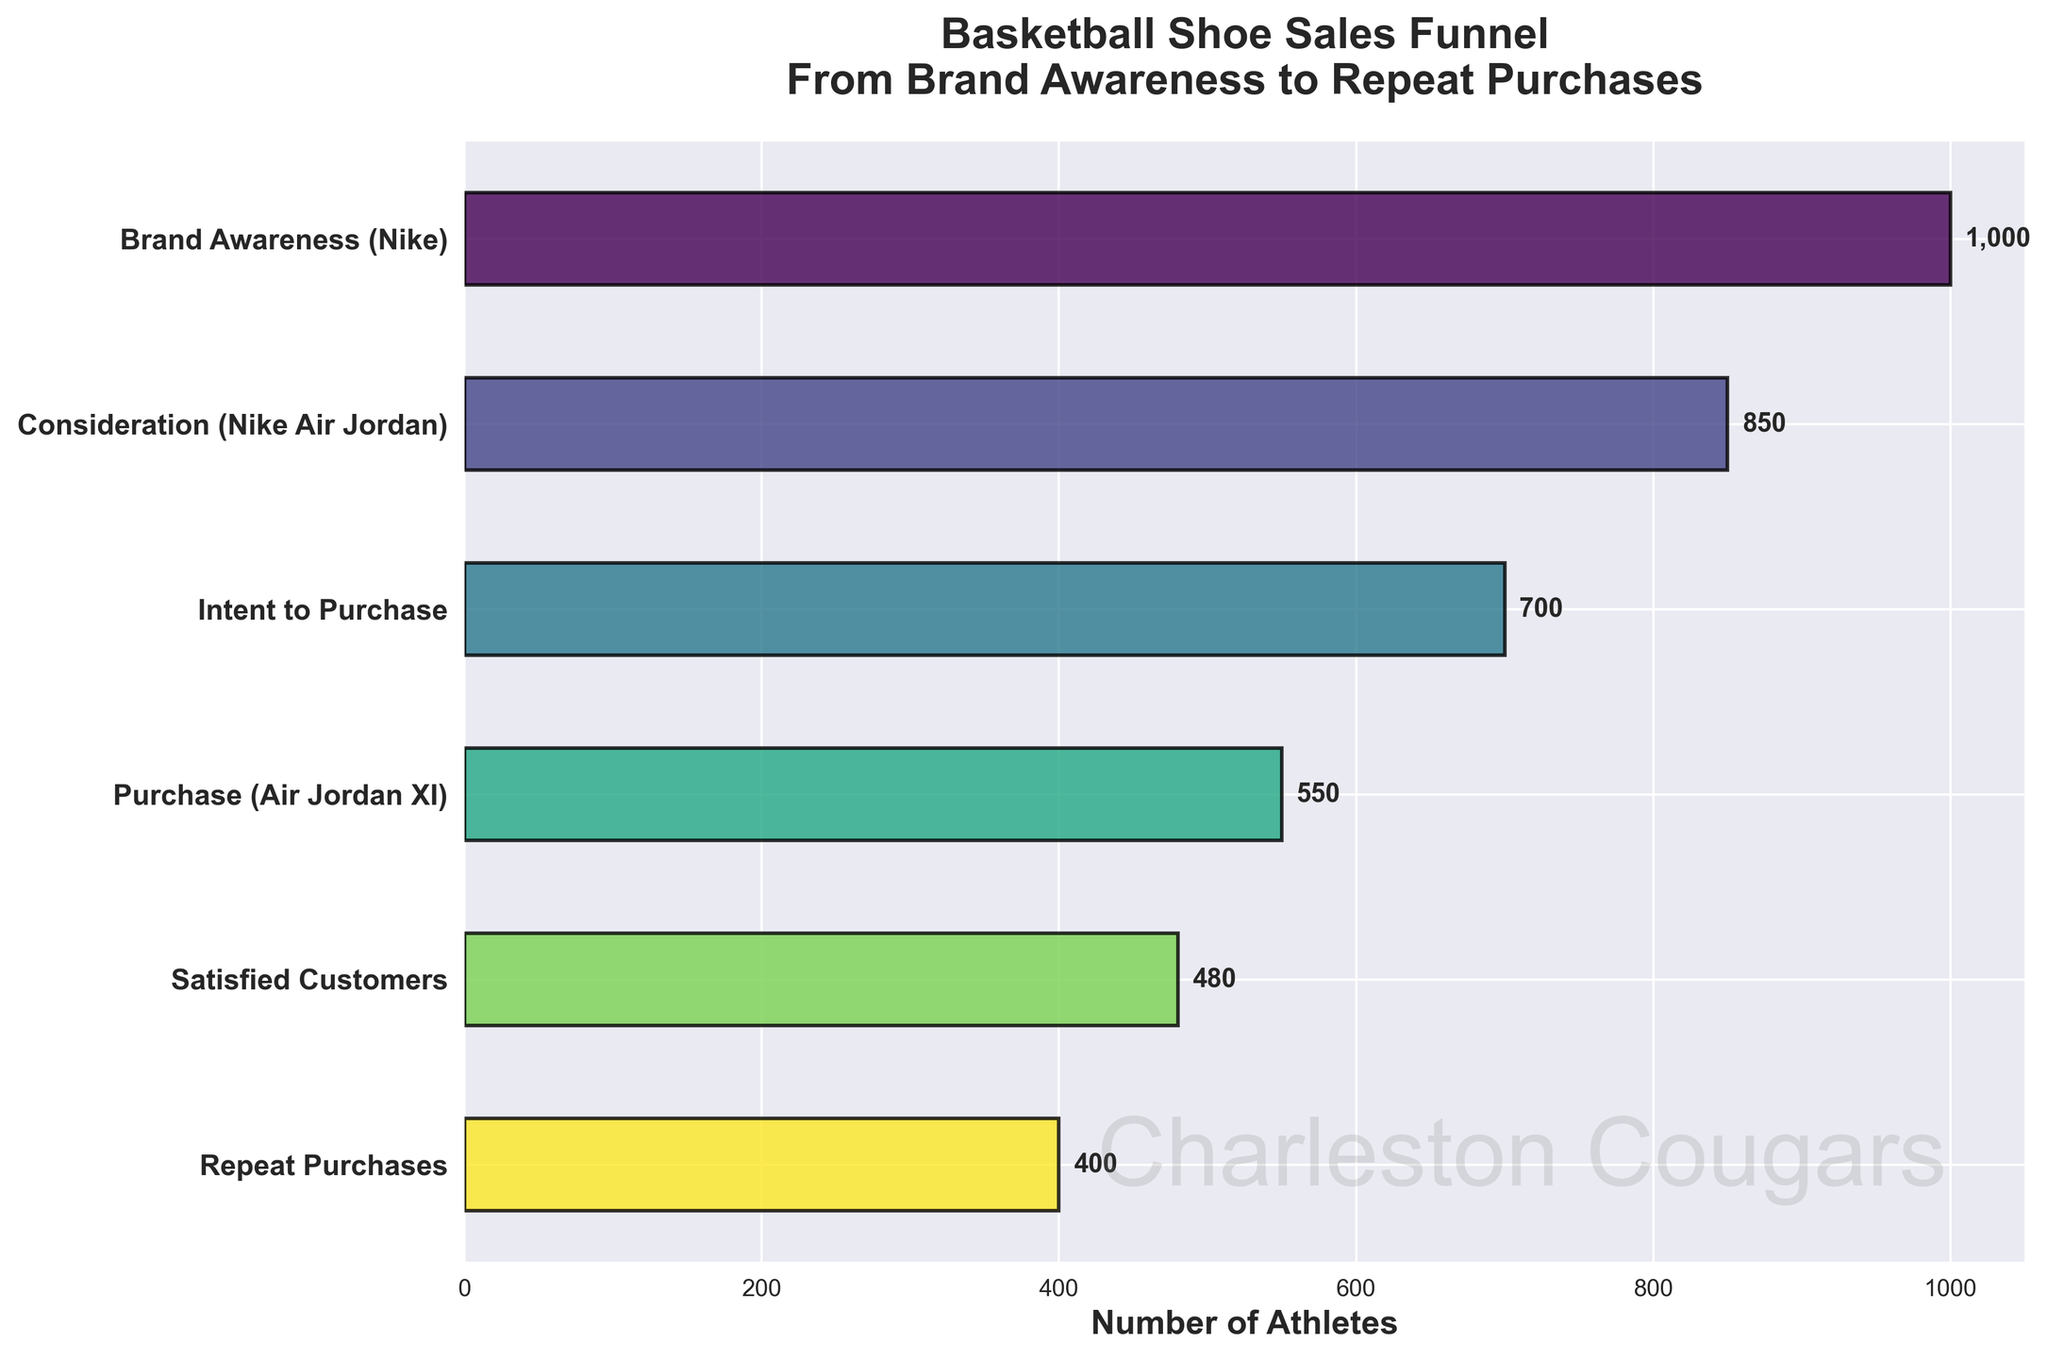What's the title of the chart? The title can be found at the top of the chart, and it describes the purpose or content of the chart.
Answer: Basketball Shoe Sales Funnel: From Brand Awareness to Repeat Purchases How many stages are there in the funnel? Count the distinct stages listed on the y-axis of the chart.
Answer: 6 Which stage has the most athletes? Look for the bar that is the longest, which represents the highest value on the x-axis.
Answer: Brand Awareness (Nike) What is the number of athletes at the Satisfied Customers stage? Look at the length of the bar corresponding to "Satisfied Customers" and read the label directly.
Answer: 480 How many athletes drop off from the Purchase to the Repeat Purchases stage? Subtract the number of athletes at the Repeat Purchases stage from the number at the Purchase stage: 550 - 400.
Answer: 150 What percentage of athletes who have brand awareness eventually make a purchase? Divide the number of athletes who made a purchase by those who have brand awareness and multiply by 100: (550 / 1000) * 100%.
Answer: 55% Compare the number of athletes considering Nike Air Jordan to those intending to purchase. Find the difference between the two stages: 850 (Consideration) - 700 (Intent to Purchase).
Answer: 150 What is the difference in the number of athletes between Brand Awareness and Repeat Purchases? Subtract the number at Repeat Purchases from Brand Awareness: 1000 - 400.
Answer: 600 